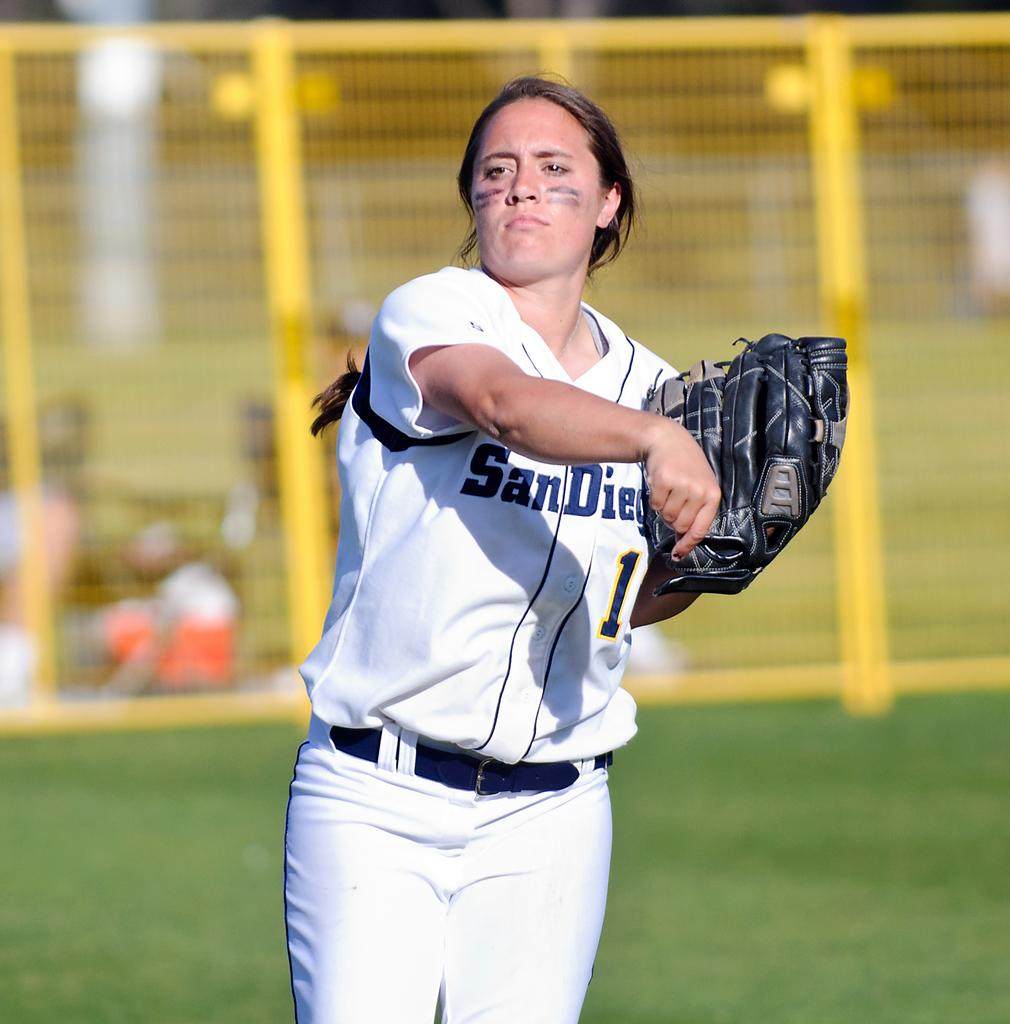<image>
Summarize the visual content of the image. Baseball player wearing a jersey which says San Diego on it. 